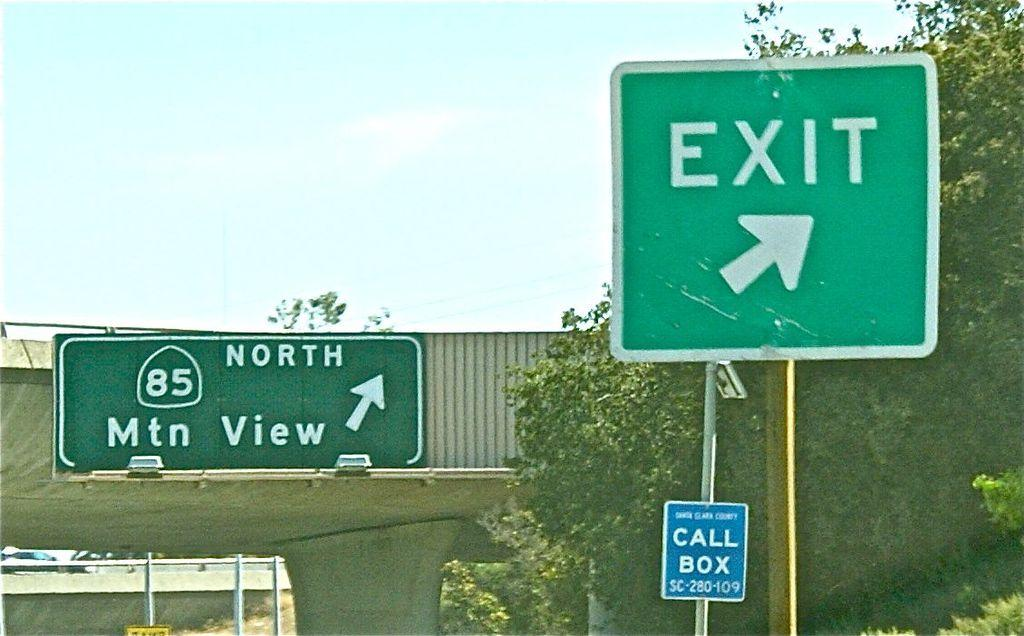Provide a one-sentence caption for the provided image. An exit sign just before the North 85 ramp. 